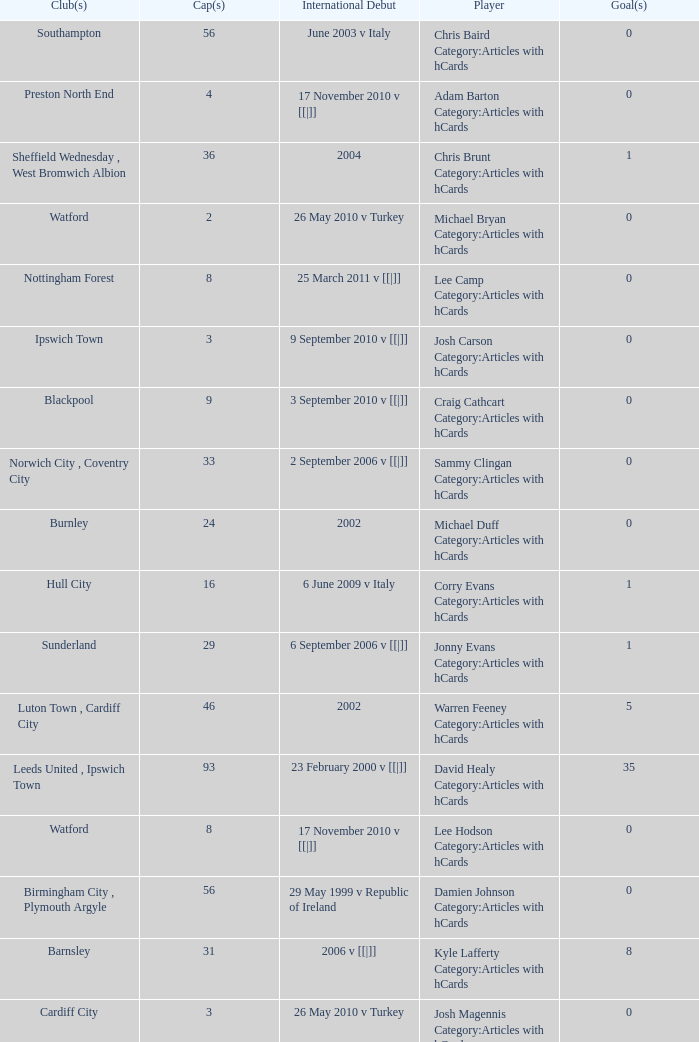How many caps figures are there for Norwich City, Coventry City? 1.0. 